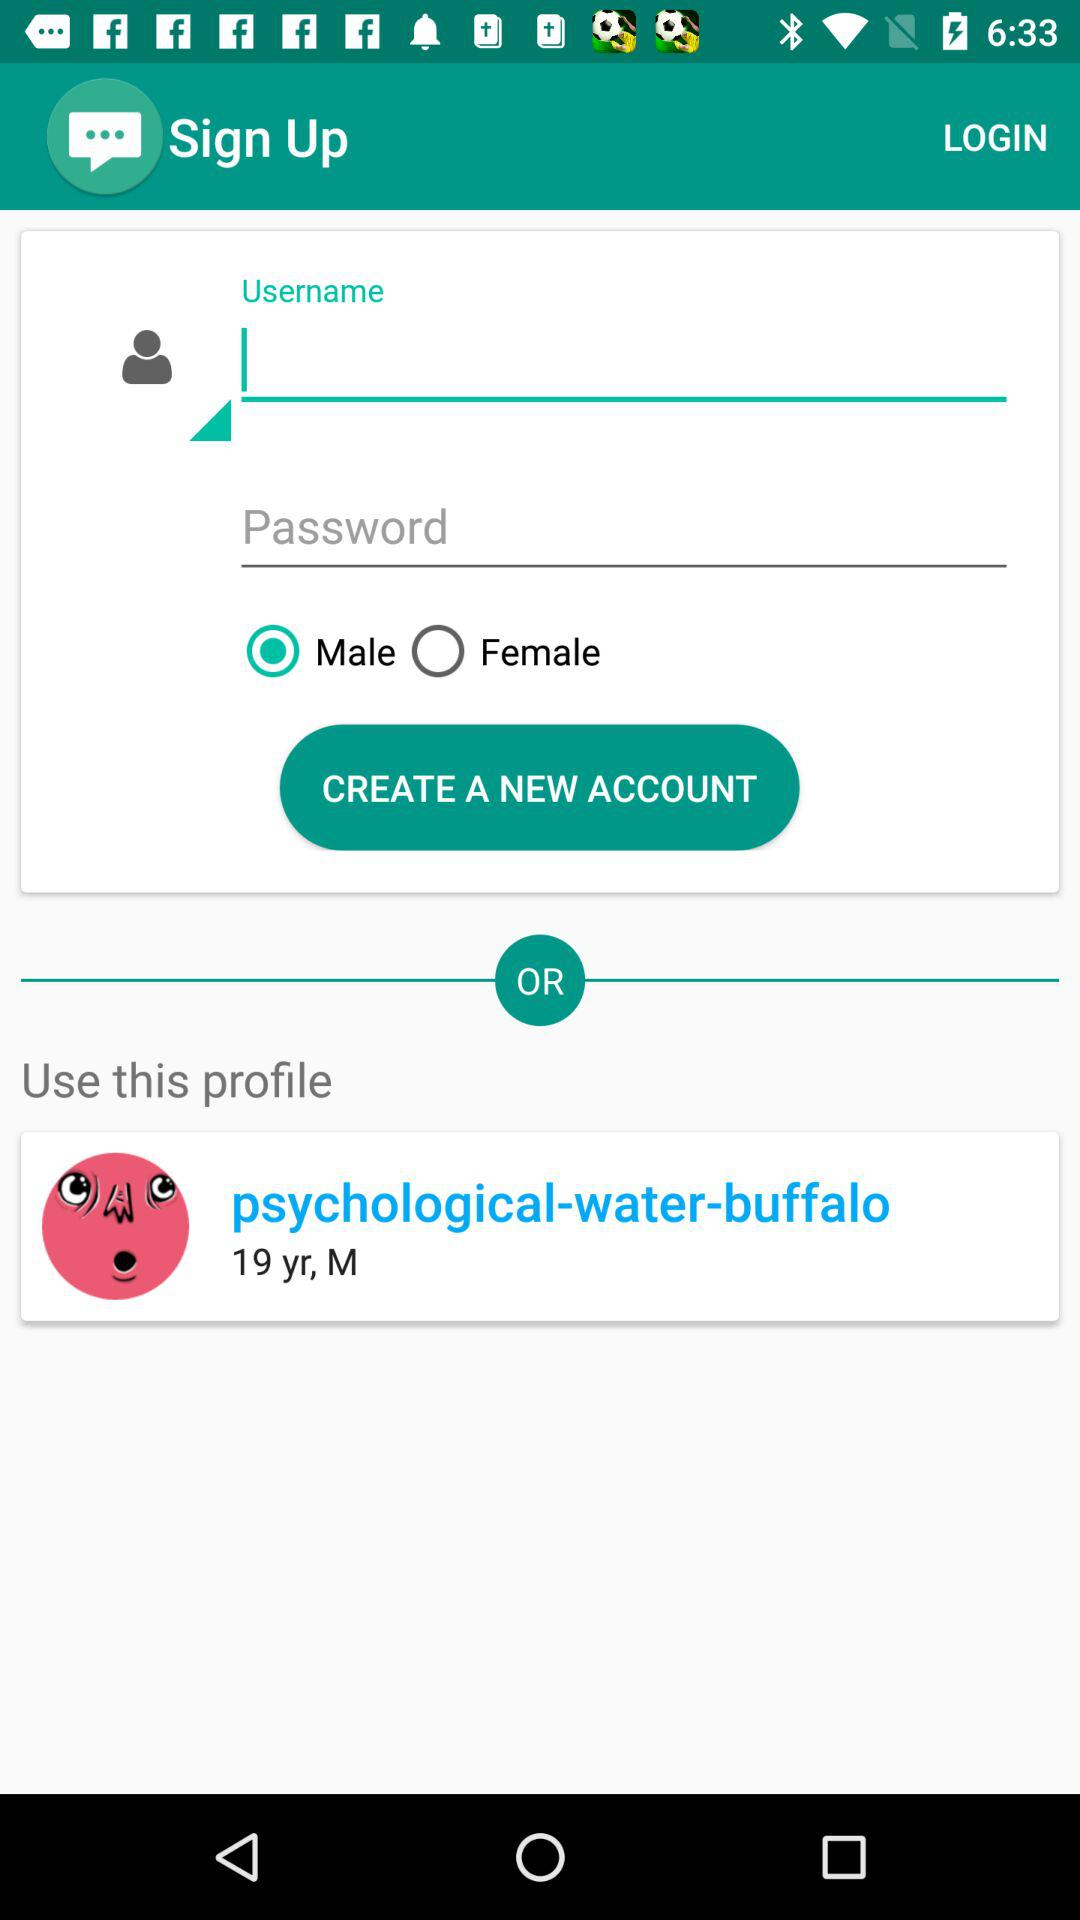What is the age of "psychological-water-buffalo"? The age of "psychological-water-buffalo" is 19 years. 